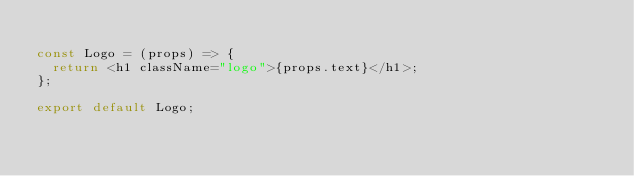<code> <loc_0><loc_0><loc_500><loc_500><_JavaScript_>
const Logo = (props) => {
  return <h1 className="logo">{props.text}</h1>;
};

export default Logo;
</code> 